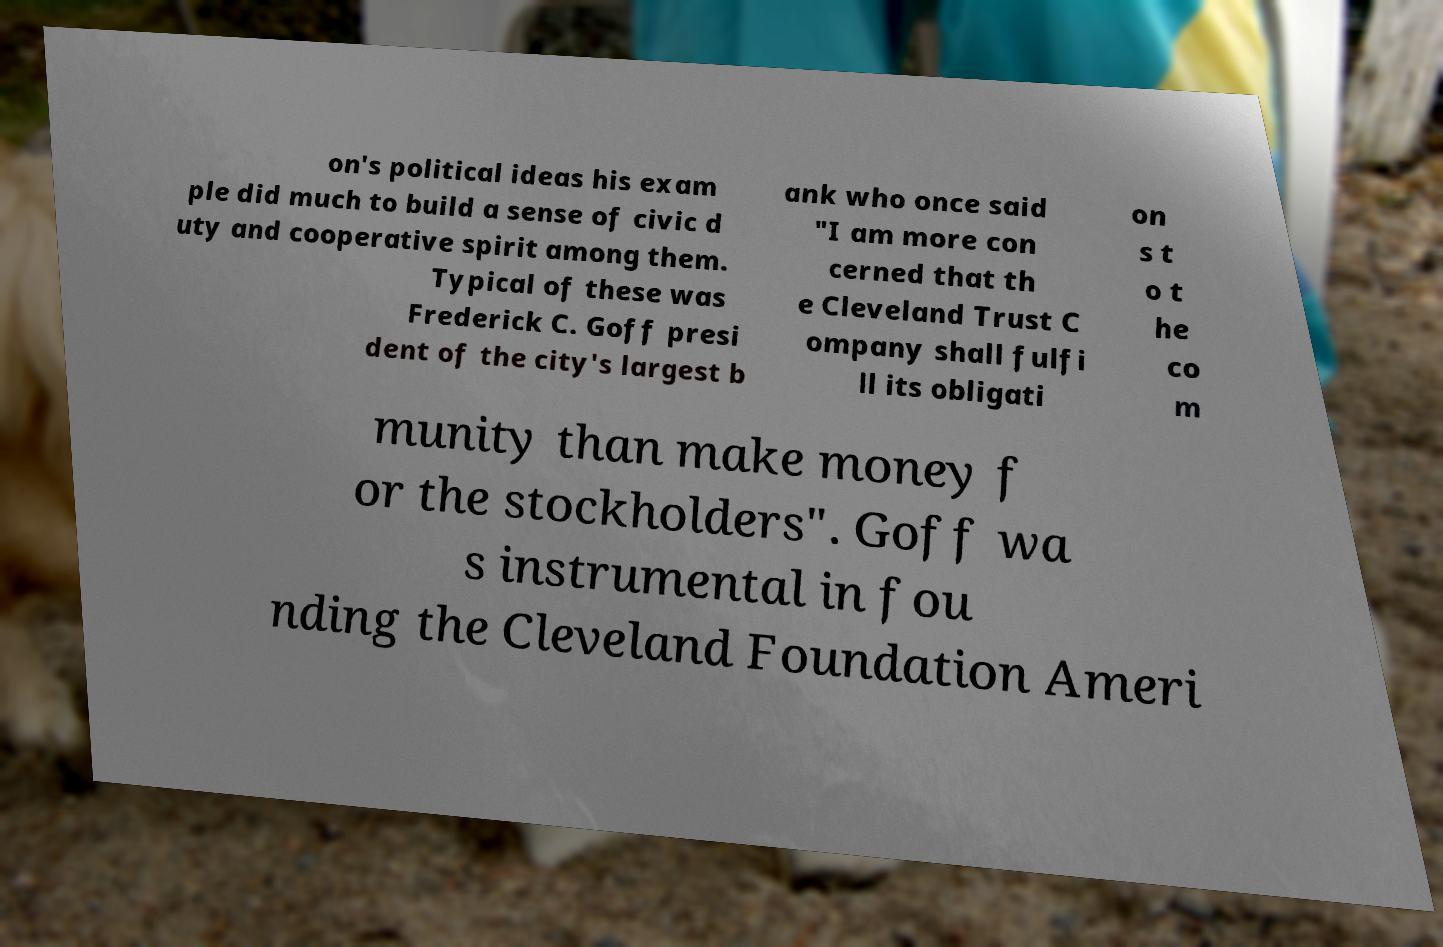Can you read and provide the text displayed in the image?This photo seems to have some interesting text. Can you extract and type it out for me? on's political ideas his exam ple did much to build a sense of civic d uty and cooperative spirit among them. Typical of these was Frederick C. Goff presi dent of the city's largest b ank who once said "I am more con cerned that th e Cleveland Trust C ompany shall fulfi ll its obligati on s t o t he co m munity than make money f or the stockholders". Goff wa s instrumental in fou nding the Cleveland Foundation Ameri 